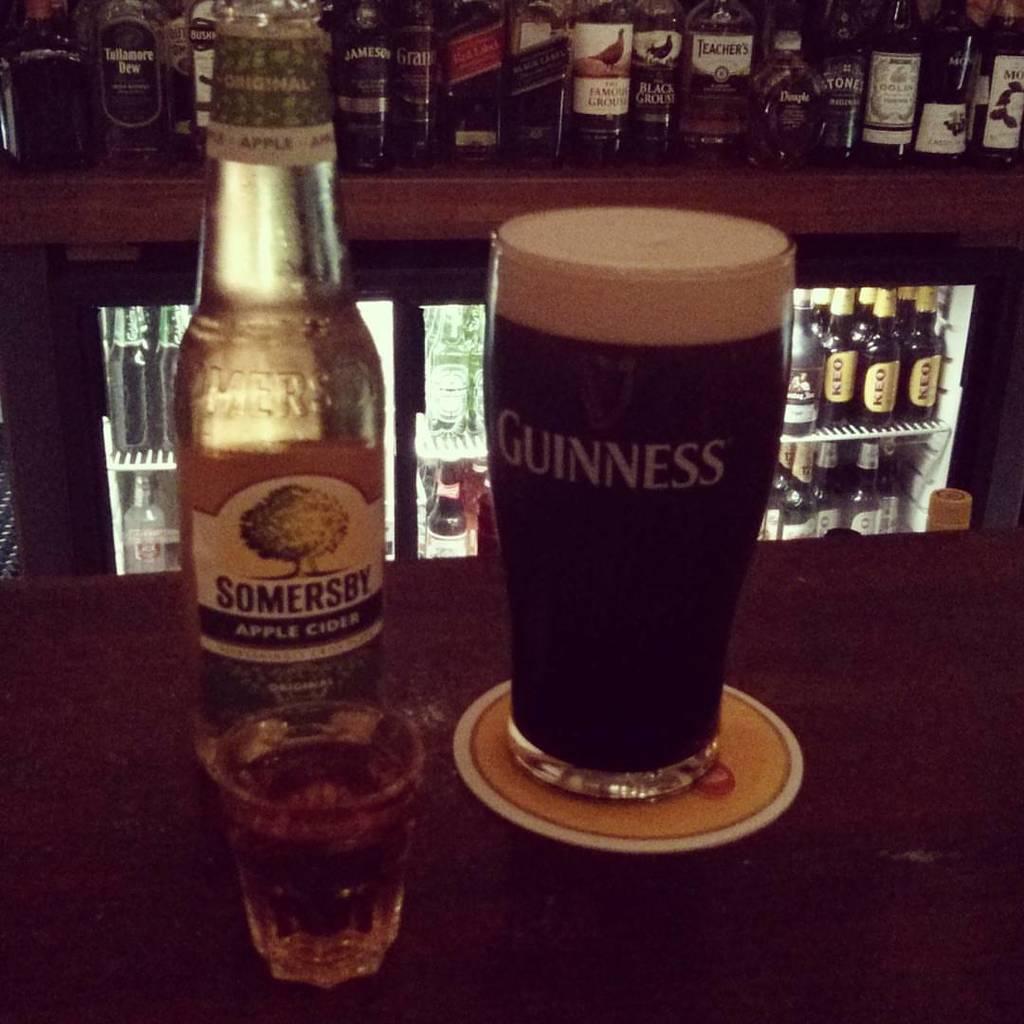What brand of beer is it?
Provide a short and direct response. Guinness. What is the left bottle ?
Make the answer very short. Somersby apple cider. 